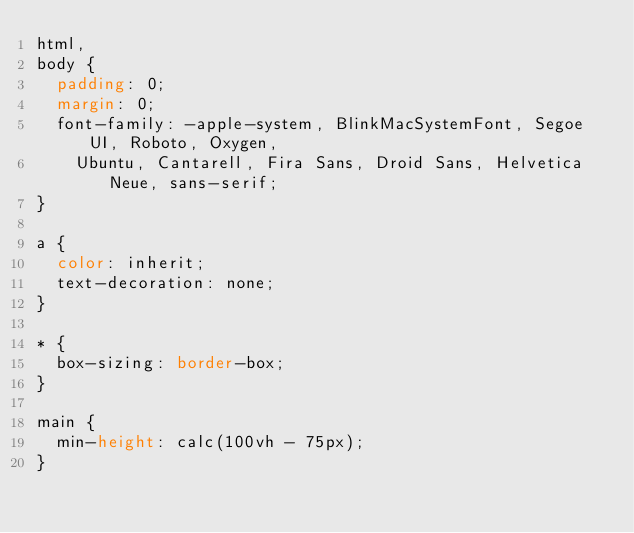Convert code to text. <code><loc_0><loc_0><loc_500><loc_500><_CSS_>html,
body {
  padding: 0;
  margin: 0;
  font-family: -apple-system, BlinkMacSystemFont, Segoe UI, Roboto, Oxygen,
    Ubuntu, Cantarell, Fira Sans, Droid Sans, Helvetica Neue, sans-serif;
}

a {
  color: inherit;
  text-decoration: none;
}

* {
  box-sizing: border-box;
}

main {
  min-height: calc(100vh - 75px);
}
</code> 